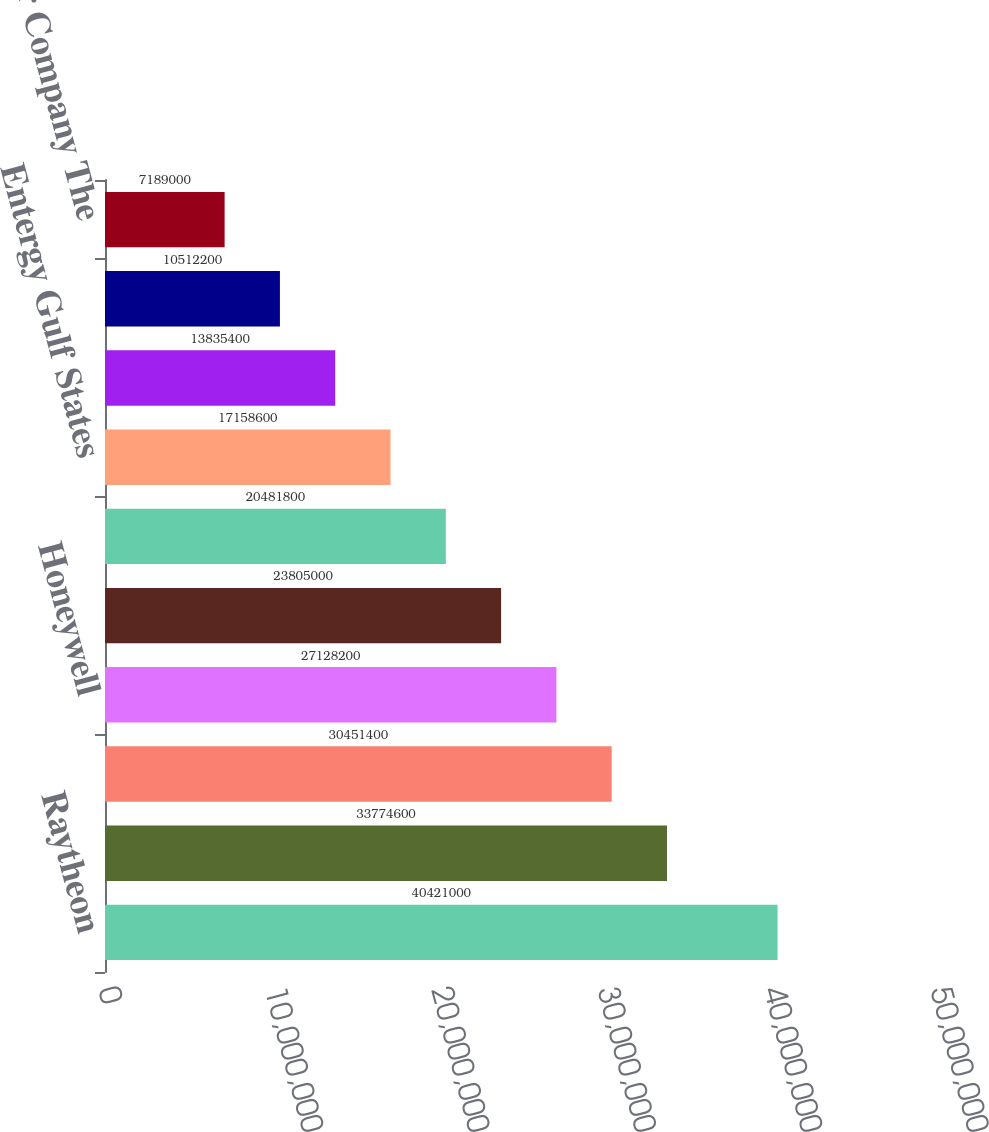<chart> <loc_0><loc_0><loc_500><loc_500><bar_chart><fcel>Raytheon<fcel>The Saint Paul Co<fcel>Albertson's Inc<fcel>Honeywell<fcel>Federal Express<fcel>Owens-Illinois<fcel>Entergy Gulf States<fcel>Safeway Inc<fcel>Hibernia Bank<fcel>Nevada Power Company The<nl><fcel>4.0421e+07<fcel>3.37746e+07<fcel>3.04514e+07<fcel>2.71282e+07<fcel>2.3805e+07<fcel>2.04818e+07<fcel>1.71586e+07<fcel>1.38354e+07<fcel>1.05122e+07<fcel>7.189e+06<nl></chart> 